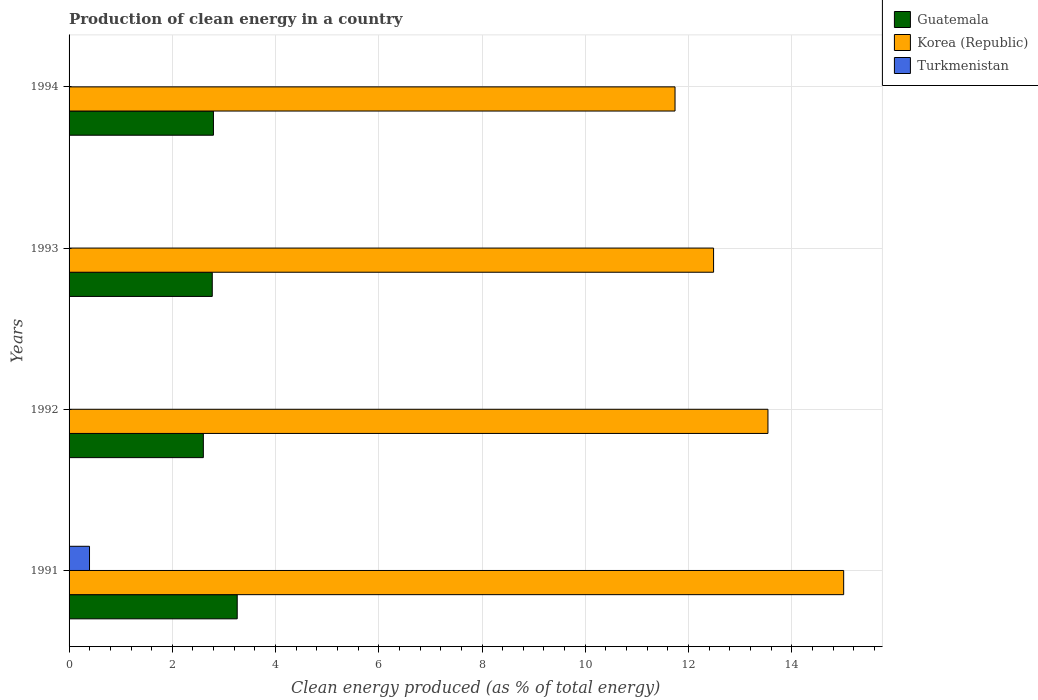How many different coloured bars are there?
Provide a short and direct response. 3. How many bars are there on the 3rd tick from the bottom?
Your answer should be very brief. 3. In how many cases, is the number of bars for a given year not equal to the number of legend labels?
Offer a terse response. 0. What is the percentage of clean energy produced in Guatemala in 1991?
Your answer should be very brief. 3.26. Across all years, what is the maximum percentage of clean energy produced in Guatemala?
Provide a short and direct response. 3.26. Across all years, what is the minimum percentage of clean energy produced in Turkmenistan?
Ensure brevity in your answer.  0. What is the total percentage of clean energy produced in Korea (Republic) in the graph?
Provide a short and direct response. 52.77. What is the difference between the percentage of clean energy produced in Turkmenistan in 1991 and that in 1993?
Keep it short and to the point. 0.39. What is the difference between the percentage of clean energy produced in Guatemala in 1993 and the percentage of clean energy produced in Turkmenistan in 1992?
Your answer should be compact. 2.77. What is the average percentage of clean energy produced in Guatemala per year?
Keep it short and to the point. 2.86. In the year 1991, what is the difference between the percentage of clean energy produced in Korea (Republic) and percentage of clean energy produced in Guatemala?
Give a very brief answer. 11.75. In how many years, is the percentage of clean energy produced in Guatemala greater than 1.2000000000000002 %?
Give a very brief answer. 4. What is the ratio of the percentage of clean energy produced in Korea (Republic) in 1993 to that in 1994?
Offer a very short reply. 1.06. Is the percentage of clean energy produced in Guatemala in 1992 less than that in 1994?
Keep it short and to the point. Yes. Is the difference between the percentage of clean energy produced in Korea (Republic) in 1991 and 1992 greater than the difference between the percentage of clean energy produced in Guatemala in 1991 and 1992?
Ensure brevity in your answer.  Yes. What is the difference between the highest and the second highest percentage of clean energy produced in Korea (Republic)?
Your answer should be compact. 1.47. What is the difference between the highest and the lowest percentage of clean energy produced in Guatemala?
Your answer should be very brief. 0.66. In how many years, is the percentage of clean energy produced in Korea (Republic) greater than the average percentage of clean energy produced in Korea (Republic) taken over all years?
Your answer should be very brief. 2. What does the 2nd bar from the bottom in 1993 represents?
Your answer should be very brief. Korea (Republic). Is it the case that in every year, the sum of the percentage of clean energy produced in Guatemala and percentage of clean energy produced in Korea (Republic) is greater than the percentage of clean energy produced in Turkmenistan?
Offer a terse response. Yes. How many years are there in the graph?
Offer a very short reply. 4. What is the difference between two consecutive major ticks on the X-axis?
Offer a very short reply. 2. Does the graph contain grids?
Offer a terse response. Yes. How are the legend labels stacked?
Your answer should be compact. Vertical. What is the title of the graph?
Offer a very short reply. Production of clean energy in a country. Does "Swaziland" appear as one of the legend labels in the graph?
Offer a very short reply. No. What is the label or title of the X-axis?
Offer a terse response. Clean energy produced (as % of total energy). What is the Clean energy produced (as % of total energy) of Guatemala in 1991?
Your answer should be very brief. 3.26. What is the Clean energy produced (as % of total energy) of Korea (Republic) in 1991?
Your answer should be compact. 15.01. What is the Clean energy produced (as % of total energy) in Turkmenistan in 1991?
Give a very brief answer. 0.4. What is the Clean energy produced (as % of total energy) in Guatemala in 1992?
Give a very brief answer. 2.6. What is the Clean energy produced (as % of total energy) in Korea (Republic) in 1992?
Make the answer very short. 13.54. What is the Clean energy produced (as % of total energy) in Turkmenistan in 1992?
Provide a succinct answer. 0. What is the Clean energy produced (as % of total energy) in Guatemala in 1993?
Your answer should be very brief. 2.77. What is the Clean energy produced (as % of total energy) of Korea (Republic) in 1993?
Your answer should be very brief. 12.49. What is the Clean energy produced (as % of total energy) in Turkmenistan in 1993?
Your answer should be very brief. 0. What is the Clean energy produced (as % of total energy) in Guatemala in 1994?
Offer a very short reply. 2.8. What is the Clean energy produced (as % of total energy) in Korea (Republic) in 1994?
Offer a very short reply. 11.74. What is the Clean energy produced (as % of total energy) in Turkmenistan in 1994?
Ensure brevity in your answer.  0. Across all years, what is the maximum Clean energy produced (as % of total energy) of Guatemala?
Your answer should be very brief. 3.26. Across all years, what is the maximum Clean energy produced (as % of total energy) in Korea (Republic)?
Your answer should be very brief. 15.01. Across all years, what is the maximum Clean energy produced (as % of total energy) in Turkmenistan?
Provide a short and direct response. 0.4. Across all years, what is the minimum Clean energy produced (as % of total energy) in Guatemala?
Offer a terse response. 2.6. Across all years, what is the minimum Clean energy produced (as % of total energy) of Korea (Republic)?
Your response must be concise. 11.74. Across all years, what is the minimum Clean energy produced (as % of total energy) in Turkmenistan?
Your response must be concise. 0. What is the total Clean energy produced (as % of total energy) in Guatemala in the graph?
Offer a very short reply. 11.43. What is the total Clean energy produced (as % of total energy) of Korea (Republic) in the graph?
Your answer should be very brief. 52.77. What is the total Clean energy produced (as % of total energy) in Turkmenistan in the graph?
Offer a very short reply. 0.41. What is the difference between the Clean energy produced (as % of total energy) of Guatemala in 1991 and that in 1992?
Your answer should be very brief. 0.66. What is the difference between the Clean energy produced (as % of total energy) of Korea (Republic) in 1991 and that in 1992?
Your answer should be very brief. 1.47. What is the difference between the Clean energy produced (as % of total energy) in Turkmenistan in 1991 and that in 1992?
Your answer should be very brief. 0.39. What is the difference between the Clean energy produced (as % of total energy) of Guatemala in 1991 and that in 1993?
Your response must be concise. 0.48. What is the difference between the Clean energy produced (as % of total energy) in Korea (Republic) in 1991 and that in 1993?
Keep it short and to the point. 2.52. What is the difference between the Clean energy produced (as % of total energy) of Turkmenistan in 1991 and that in 1993?
Your answer should be compact. 0.39. What is the difference between the Clean energy produced (as % of total energy) in Guatemala in 1991 and that in 1994?
Provide a succinct answer. 0.46. What is the difference between the Clean energy produced (as % of total energy) of Korea (Republic) in 1991 and that in 1994?
Provide a short and direct response. 3.27. What is the difference between the Clean energy produced (as % of total energy) in Turkmenistan in 1991 and that in 1994?
Provide a short and direct response. 0.39. What is the difference between the Clean energy produced (as % of total energy) of Guatemala in 1992 and that in 1993?
Give a very brief answer. -0.17. What is the difference between the Clean energy produced (as % of total energy) in Korea (Republic) in 1992 and that in 1993?
Your answer should be compact. 1.05. What is the difference between the Clean energy produced (as % of total energy) of Turkmenistan in 1992 and that in 1993?
Give a very brief answer. -0. What is the difference between the Clean energy produced (as % of total energy) of Guatemala in 1992 and that in 1994?
Keep it short and to the point. -0.2. What is the difference between the Clean energy produced (as % of total energy) in Turkmenistan in 1992 and that in 1994?
Your answer should be compact. 0. What is the difference between the Clean energy produced (as % of total energy) in Guatemala in 1993 and that in 1994?
Ensure brevity in your answer.  -0.02. What is the difference between the Clean energy produced (as % of total energy) in Korea (Republic) in 1993 and that in 1994?
Your response must be concise. 0.75. What is the difference between the Clean energy produced (as % of total energy) of Turkmenistan in 1993 and that in 1994?
Keep it short and to the point. 0. What is the difference between the Clean energy produced (as % of total energy) of Guatemala in 1991 and the Clean energy produced (as % of total energy) of Korea (Republic) in 1992?
Give a very brief answer. -10.28. What is the difference between the Clean energy produced (as % of total energy) of Guatemala in 1991 and the Clean energy produced (as % of total energy) of Turkmenistan in 1992?
Your answer should be compact. 3.25. What is the difference between the Clean energy produced (as % of total energy) in Korea (Republic) in 1991 and the Clean energy produced (as % of total energy) in Turkmenistan in 1992?
Your answer should be compact. 15. What is the difference between the Clean energy produced (as % of total energy) in Guatemala in 1991 and the Clean energy produced (as % of total energy) in Korea (Republic) in 1993?
Provide a short and direct response. -9.23. What is the difference between the Clean energy produced (as % of total energy) of Guatemala in 1991 and the Clean energy produced (as % of total energy) of Turkmenistan in 1993?
Provide a short and direct response. 3.25. What is the difference between the Clean energy produced (as % of total energy) of Korea (Republic) in 1991 and the Clean energy produced (as % of total energy) of Turkmenistan in 1993?
Keep it short and to the point. 15. What is the difference between the Clean energy produced (as % of total energy) in Guatemala in 1991 and the Clean energy produced (as % of total energy) in Korea (Republic) in 1994?
Provide a short and direct response. -8.48. What is the difference between the Clean energy produced (as % of total energy) in Guatemala in 1991 and the Clean energy produced (as % of total energy) in Turkmenistan in 1994?
Keep it short and to the point. 3.25. What is the difference between the Clean energy produced (as % of total energy) in Korea (Republic) in 1991 and the Clean energy produced (as % of total energy) in Turkmenistan in 1994?
Keep it short and to the point. 15. What is the difference between the Clean energy produced (as % of total energy) of Guatemala in 1992 and the Clean energy produced (as % of total energy) of Korea (Republic) in 1993?
Provide a succinct answer. -9.88. What is the difference between the Clean energy produced (as % of total energy) in Guatemala in 1992 and the Clean energy produced (as % of total energy) in Turkmenistan in 1993?
Your answer should be compact. 2.6. What is the difference between the Clean energy produced (as % of total energy) in Korea (Republic) in 1992 and the Clean energy produced (as % of total energy) in Turkmenistan in 1993?
Your answer should be compact. 13.54. What is the difference between the Clean energy produced (as % of total energy) of Guatemala in 1992 and the Clean energy produced (as % of total energy) of Korea (Republic) in 1994?
Your response must be concise. -9.14. What is the difference between the Clean energy produced (as % of total energy) of Guatemala in 1992 and the Clean energy produced (as % of total energy) of Turkmenistan in 1994?
Ensure brevity in your answer.  2.6. What is the difference between the Clean energy produced (as % of total energy) of Korea (Republic) in 1992 and the Clean energy produced (as % of total energy) of Turkmenistan in 1994?
Offer a very short reply. 13.54. What is the difference between the Clean energy produced (as % of total energy) of Guatemala in 1993 and the Clean energy produced (as % of total energy) of Korea (Republic) in 1994?
Your response must be concise. -8.97. What is the difference between the Clean energy produced (as % of total energy) of Guatemala in 1993 and the Clean energy produced (as % of total energy) of Turkmenistan in 1994?
Offer a terse response. 2.77. What is the difference between the Clean energy produced (as % of total energy) of Korea (Republic) in 1993 and the Clean energy produced (as % of total energy) of Turkmenistan in 1994?
Keep it short and to the point. 12.48. What is the average Clean energy produced (as % of total energy) in Guatemala per year?
Provide a succinct answer. 2.86. What is the average Clean energy produced (as % of total energy) in Korea (Republic) per year?
Your answer should be very brief. 13.19. What is the average Clean energy produced (as % of total energy) of Turkmenistan per year?
Your response must be concise. 0.1. In the year 1991, what is the difference between the Clean energy produced (as % of total energy) of Guatemala and Clean energy produced (as % of total energy) of Korea (Republic)?
Offer a very short reply. -11.75. In the year 1991, what is the difference between the Clean energy produced (as % of total energy) in Guatemala and Clean energy produced (as % of total energy) in Turkmenistan?
Offer a very short reply. 2.86. In the year 1991, what is the difference between the Clean energy produced (as % of total energy) in Korea (Republic) and Clean energy produced (as % of total energy) in Turkmenistan?
Provide a short and direct response. 14.61. In the year 1992, what is the difference between the Clean energy produced (as % of total energy) in Guatemala and Clean energy produced (as % of total energy) in Korea (Republic)?
Offer a terse response. -10.94. In the year 1992, what is the difference between the Clean energy produced (as % of total energy) of Guatemala and Clean energy produced (as % of total energy) of Turkmenistan?
Offer a very short reply. 2.6. In the year 1992, what is the difference between the Clean energy produced (as % of total energy) in Korea (Republic) and Clean energy produced (as % of total energy) in Turkmenistan?
Offer a very short reply. 13.54. In the year 1993, what is the difference between the Clean energy produced (as % of total energy) of Guatemala and Clean energy produced (as % of total energy) of Korea (Republic)?
Your answer should be very brief. -9.71. In the year 1993, what is the difference between the Clean energy produced (as % of total energy) of Guatemala and Clean energy produced (as % of total energy) of Turkmenistan?
Keep it short and to the point. 2.77. In the year 1993, what is the difference between the Clean energy produced (as % of total energy) in Korea (Republic) and Clean energy produced (as % of total energy) in Turkmenistan?
Offer a terse response. 12.48. In the year 1994, what is the difference between the Clean energy produced (as % of total energy) of Guatemala and Clean energy produced (as % of total energy) of Korea (Republic)?
Your response must be concise. -8.94. In the year 1994, what is the difference between the Clean energy produced (as % of total energy) in Guatemala and Clean energy produced (as % of total energy) in Turkmenistan?
Provide a short and direct response. 2.79. In the year 1994, what is the difference between the Clean energy produced (as % of total energy) of Korea (Republic) and Clean energy produced (as % of total energy) of Turkmenistan?
Offer a very short reply. 11.74. What is the ratio of the Clean energy produced (as % of total energy) of Guatemala in 1991 to that in 1992?
Your answer should be compact. 1.25. What is the ratio of the Clean energy produced (as % of total energy) of Korea (Republic) in 1991 to that in 1992?
Provide a short and direct response. 1.11. What is the ratio of the Clean energy produced (as % of total energy) in Turkmenistan in 1991 to that in 1992?
Your response must be concise. 119.54. What is the ratio of the Clean energy produced (as % of total energy) in Guatemala in 1991 to that in 1993?
Offer a very short reply. 1.17. What is the ratio of the Clean energy produced (as % of total energy) of Korea (Republic) in 1991 to that in 1993?
Keep it short and to the point. 1.2. What is the ratio of the Clean energy produced (as % of total energy) of Turkmenistan in 1991 to that in 1993?
Your answer should be compact. 96.67. What is the ratio of the Clean energy produced (as % of total energy) of Guatemala in 1991 to that in 1994?
Your answer should be compact. 1.16. What is the ratio of the Clean energy produced (as % of total energy) of Korea (Republic) in 1991 to that in 1994?
Your answer should be compact. 1.28. What is the ratio of the Clean energy produced (as % of total energy) in Turkmenistan in 1991 to that in 1994?
Provide a succinct answer. 153.18. What is the ratio of the Clean energy produced (as % of total energy) of Guatemala in 1992 to that in 1993?
Make the answer very short. 0.94. What is the ratio of the Clean energy produced (as % of total energy) of Korea (Republic) in 1992 to that in 1993?
Keep it short and to the point. 1.08. What is the ratio of the Clean energy produced (as % of total energy) of Turkmenistan in 1992 to that in 1993?
Your response must be concise. 0.81. What is the ratio of the Clean energy produced (as % of total energy) of Guatemala in 1992 to that in 1994?
Ensure brevity in your answer.  0.93. What is the ratio of the Clean energy produced (as % of total energy) in Korea (Republic) in 1992 to that in 1994?
Your answer should be compact. 1.15. What is the ratio of the Clean energy produced (as % of total energy) of Turkmenistan in 1992 to that in 1994?
Offer a terse response. 1.28. What is the ratio of the Clean energy produced (as % of total energy) in Korea (Republic) in 1993 to that in 1994?
Your response must be concise. 1.06. What is the ratio of the Clean energy produced (as % of total energy) of Turkmenistan in 1993 to that in 1994?
Ensure brevity in your answer.  1.58. What is the difference between the highest and the second highest Clean energy produced (as % of total energy) of Guatemala?
Your answer should be compact. 0.46. What is the difference between the highest and the second highest Clean energy produced (as % of total energy) of Korea (Republic)?
Offer a terse response. 1.47. What is the difference between the highest and the second highest Clean energy produced (as % of total energy) of Turkmenistan?
Ensure brevity in your answer.  0.39. What is the difference between the highest and the lowest Clean energy produced (as % of total energy) of Guatemala?
Ensure brevity in your answer.  0.66. What is the difference between the highest and the lowest Clean energy produced (as % of total energy) of Korea (Republic)?
Keep it short and to the point. 3.27. What is the difference between the highest and the lowest Clean energy produced (as % of total energy) in Turkmenistan?
Your answer should be compact. 0.39. 